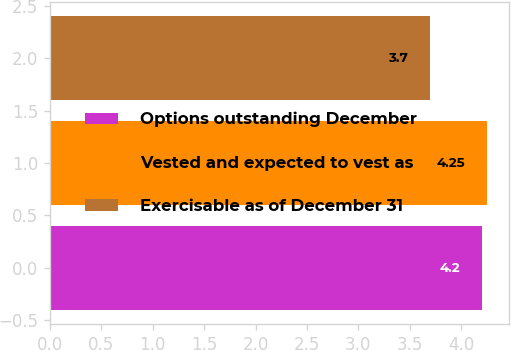<chart> <loc_0><loc_0><loc_500><loc_500><bar_chart><fcel>Options outstanding December<fcel>Vested and expected to vest as<fcel>Exercisable as of December 31<nl><fcel>4.2<fcel>4.25<fcel>3.7<nl></chart> 